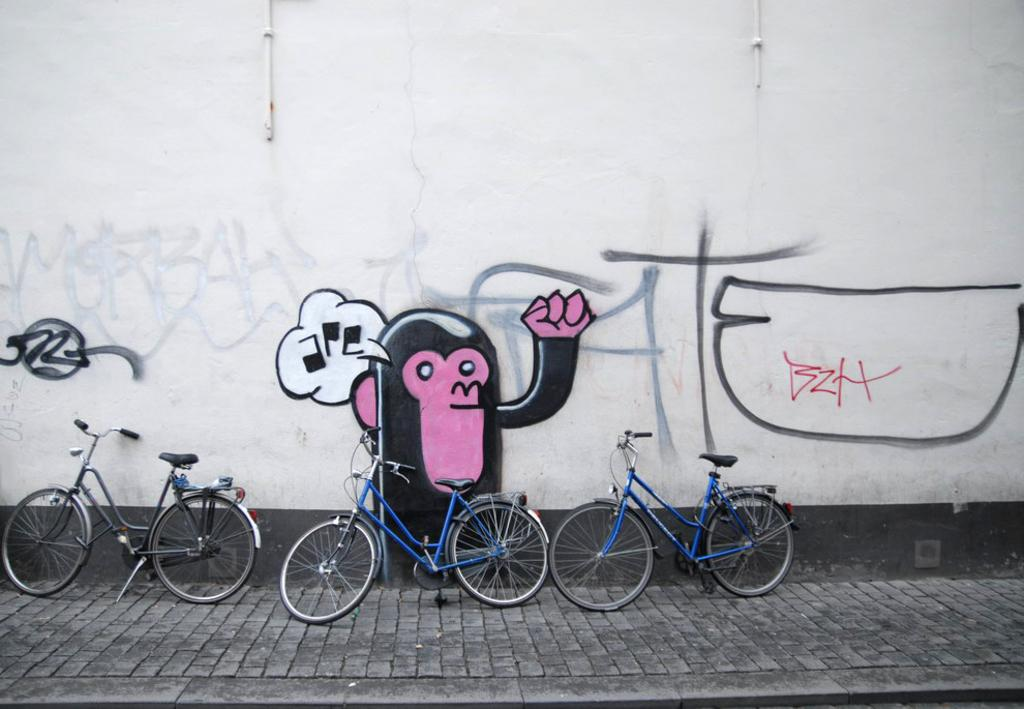What type of vehicles are in the image? There are cycles in the image. How are the cycles positioned in relation to other elements in the image? The cycles are in front of the other elements in the image. What can be seen on the wall behind the cycles? There is a painting on the wall behind the cycles. What type of berry is growing on the wall behind the cycles? There are no berries present in the image; the wall has a painting on it. 